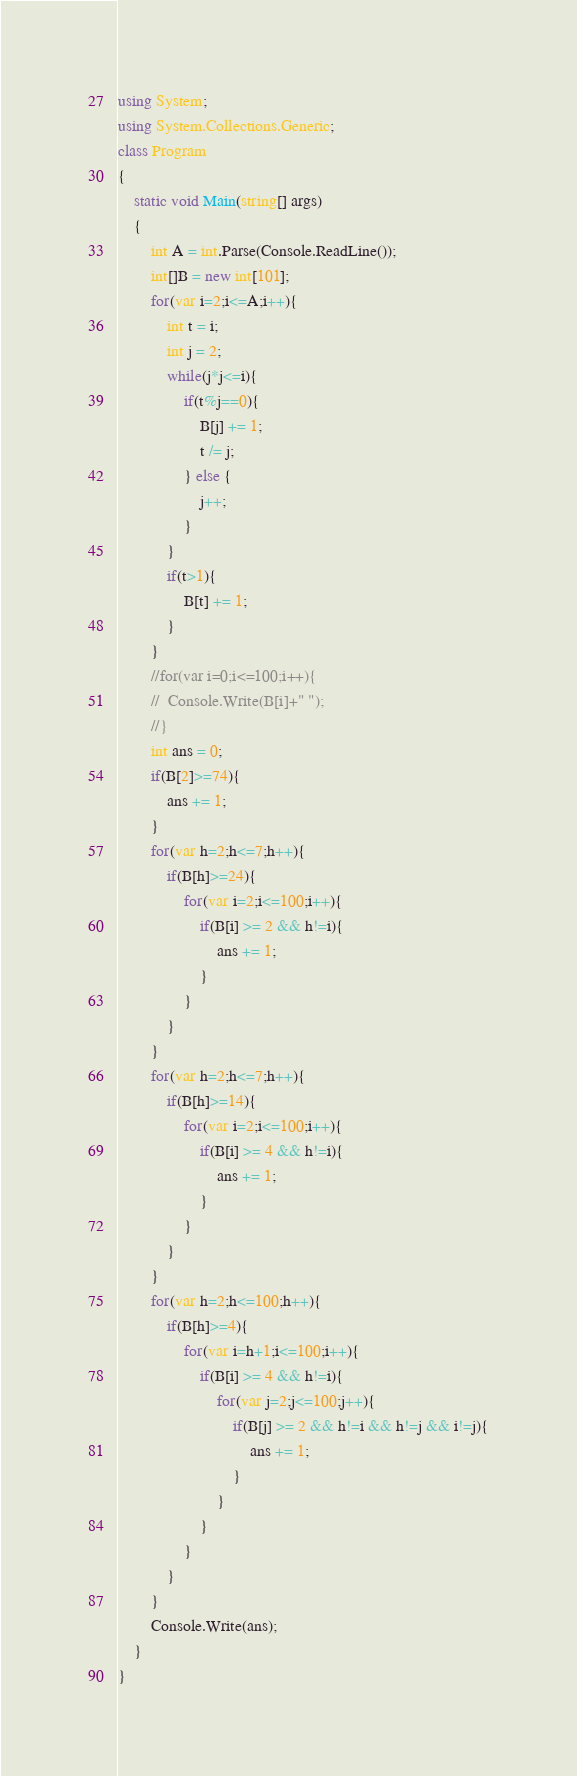<code> <loc_0><loc_0><loc_500><loc_500><_C#_>using System;
using System.Collections.Generic;
class Program
{
	static void Main(string[] args)
	{
		int A = int.Parse(Console.ReadLine());
		int[]B = new int[101];
		for(var i=2;i<=A;i++){
			int t = i;
			int j = 2;
			while(j*j<=i){
				if(t%j==0){
					B[j] += 1;
					t /= j;
				} else {
					j++;
				}
			}
			if(t>1){
				B[t] += 1;
			}
		}
		//for(var i=0;i<=100;i++){
		//	Console.Write(B[i]+" ");
		//}
		int ans = 0;
		if(B[2]>=74){
			ans += 1;
		}
		for(var h=2;h<=7;h++){
			if(B[h]>=24){
				for(var i=2;i<=100;i++){
					if(B[i] >= 2 && h!=i){
						ans += 1;
					}
				}
			}
		}
		for(var h=2;h<=7;h++){
			if(B[h]>=14){
				for(var i=2;i<=100;i++){
					if(B[i] >= 4 && h!=i){
						ans += 1;
					}
				}
			}
		}
		for(var h=2;h<=100;h++){
			if(B[h]>=4){
				for(var i=h+1;i<=100;i++){
					if(B[i] >= 4 && h!=i){
						for(var j=2;j<=100;j++){
							if(B[j] >= 2 && h!=i && h!=j && i!=j){
								ans += 1;
							}
						}
					}
				}
			}
		}
		Console.Write(ans);
	}
}</code> 